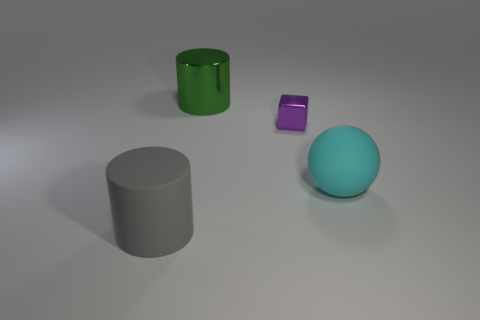Is there anything else that has the same size as the metal block?
Make the answer very short. No. Is there any other thing that has the same shape as the cyan rubber object?
Your answer should be very brief. No. Is the large metal cylinder the same color as the tiny cube?
Ensure brevity in your answer.  No. There is a gray cylinder; how many blocks are to the left of it?
Offer a very short reply. 0. Are any large blue rubber cylinders visible?
Provide a succinct answer. No. What size is the matte thing right of the matte thing on the left side of the large object on the right side of the large green metal cylinder?
Keep it short and to the point. Large. How many other objects are there of the same size as the cyan sphere?
Your response must be concise. 2. There is a rubber thing on the right side of the matte cylinder; what is its size?
Offer a terse response. Large. Is there any other thing that is the same color as the tiny block?
Your response must be concise. No. Does the large cylinder to the right of the large gray matte cylinder have the same material as the purple block?
Provide a succinct answer. Yes. 